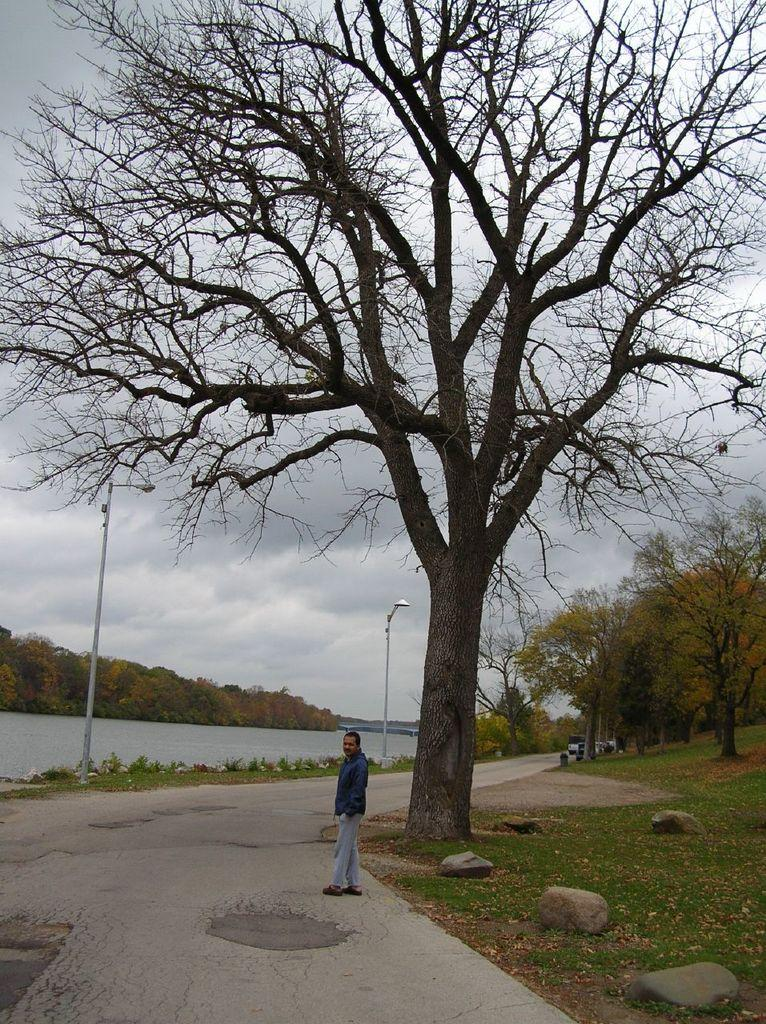What is the person in the image doing? The person is standing on a road. What can be seen in the background of the image? There is a river and poles. What is present on both sides of the image? There are trees on the left and right sides of the image. How would you describe the sky in the image? The sky is cloudy in the image. What type of advertisement can be seen on the person's stomach in the image? There is no advertisement visible on the person's stomach in the image. How does the person plan to crush the poles in the background? The person is not shown attempting to crush any poles in the image. 